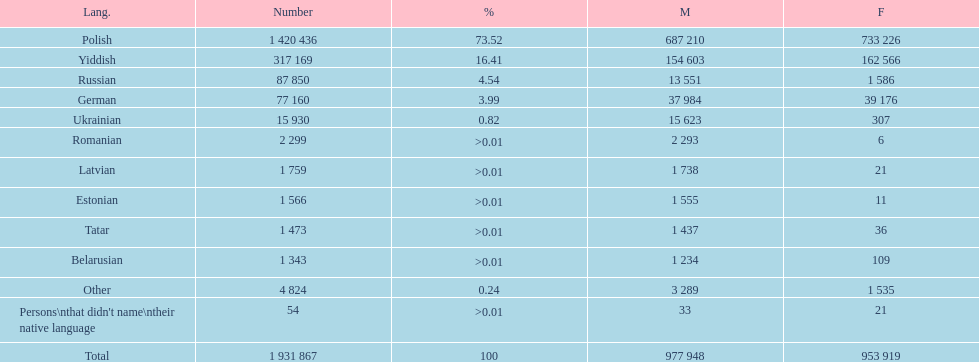Which language had the most number of people speaking it. Polish. 